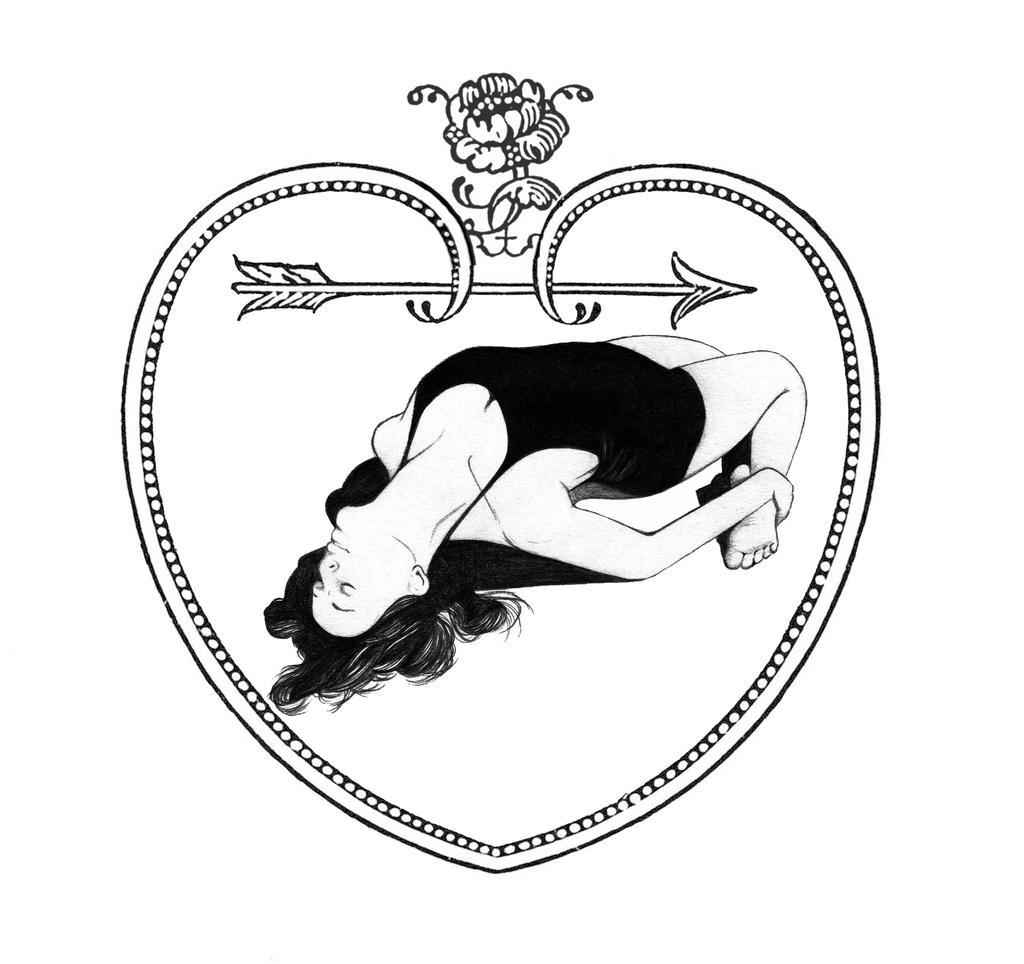Please provide a concise description of this image. This is the picture of a black and white image and we can see the drawing of a heart shaped frame and we can see a woman. 